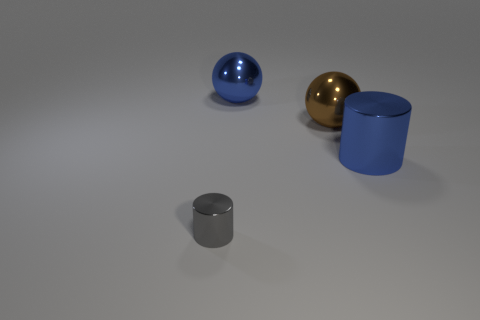Add 2 tiny cyan metal objects. How many objects exist? 6 Subtract all big cylinders. Subtract all large blue cylinders. How many objects are left? 2 Add 4 gray shiny things. How many gray shiny things are left? 5 Add 3 big blue metallic spheres. How many big blue metallic spheres exist? 4 Subtract 0 cyan cylinders. How many objects are left? 4 